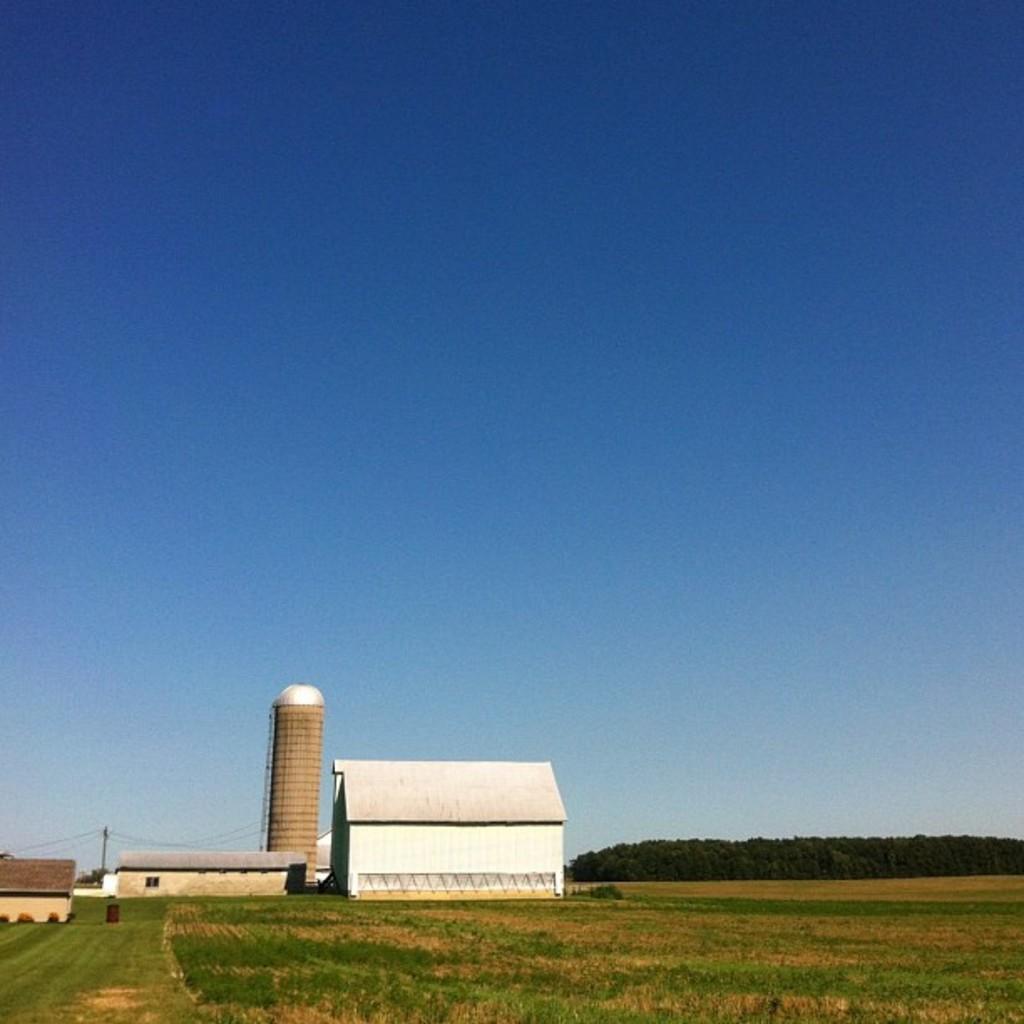Describe this image in one or two sentences. In this picture I can see few houses and I can see a tower and few trees and I can see grass on the ground and I can see blue sky. 